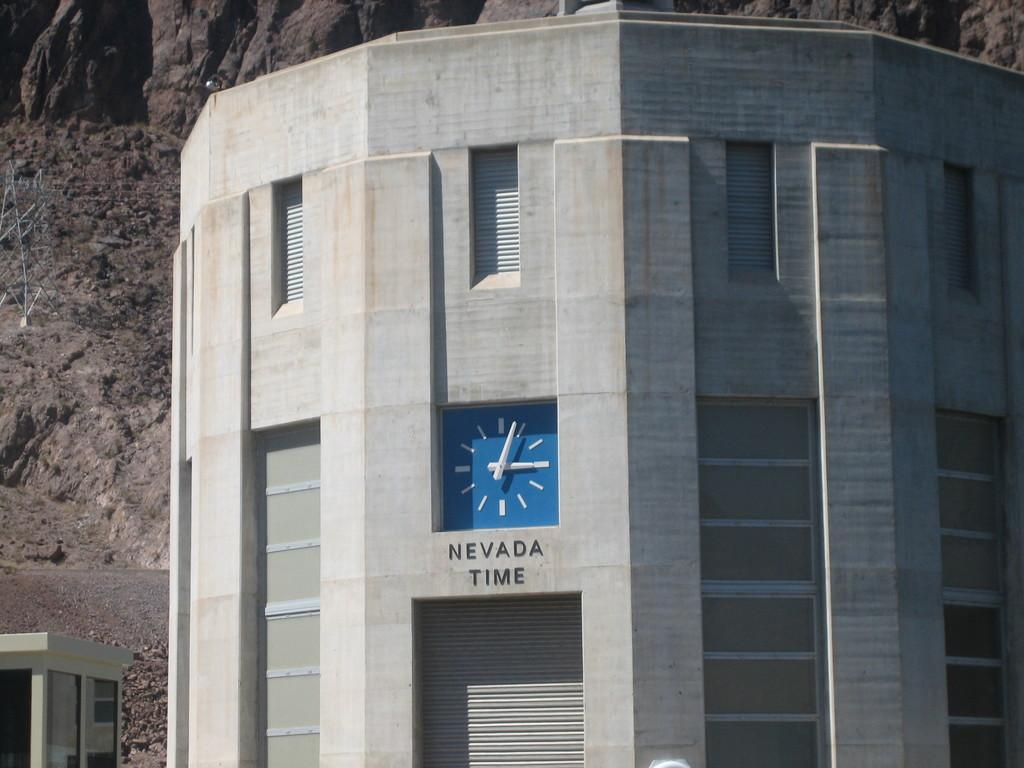Provide a one-sentence caption for the provided image. A blue clock labeled "Nevada Time" keeps time on a gray rounded structure. 